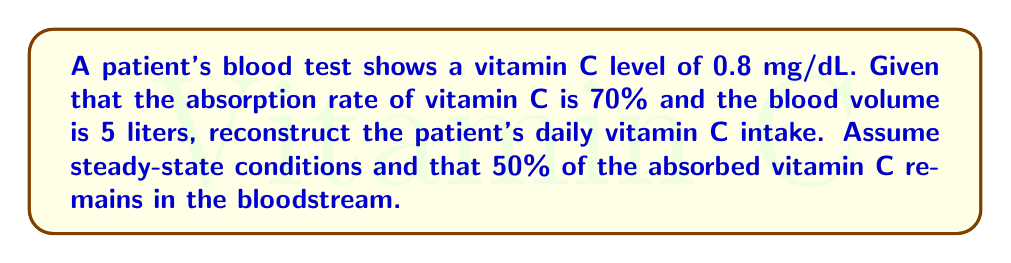Help me with this question. To reconstruct the patient's daily vitamin C intake, we'll follow these steps:

1. Calculate the total amount of vitamin C in the bloodstream:
   $$ \text{Blood vitamin C} = 0.8 \frac{\text{mg}}{\text{dL}} \times 50 \frac{\text{dL}}{\text{L}} \times 5 \text{L} = 200 \text{ mg} $$

2. Calculate the total absorbed vitamin C, given that 50% remains in the bloodstream:
   $$ \text{Absorbed vitamin C} = \frac{200 \text{ mg}}{0.50} = 400 \text{ mg} $$

3. Calculate the daily intake, considering the 70% absorption rate:
   $$ \text{Daily intake} = \frac{400 \text{ mg}}{0.70} = 571.43 \text{ mg} $$

Therefore, the patient's estimated daily vitamin C intake is approximately 571.43 mg.
Answer: 571.43 mg 